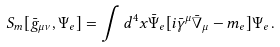<formula> <loc_0><loc_0><loc_500><loc_500>S _ { m } [ \bar { g } _ { \mu \nu } , \Psi _ { e } ] = \int d ^ { 4 } x \bar { \Psi } _ { e } [ i \bar { \gamma } ^ { \mu } \bar { \nabla } _ { \mu } - m _ { e } ] \Psi _ { e } \, .</formula> 